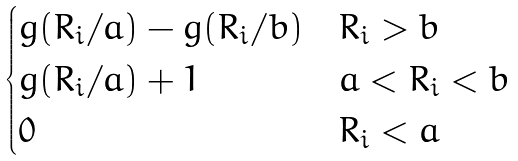Convert formula to latex. <formula><loc_0><loc_0><loc_500><loc_500>\begin{cases} g ( R _ { i } / a ) - g ( R _ { i } / b ) & R _ { i } > b \\ g ( R _ { i } / a ) + 1 & a < R _ { i } < b \\ 0 & R _ { i } < a \end{cases}</formula> 